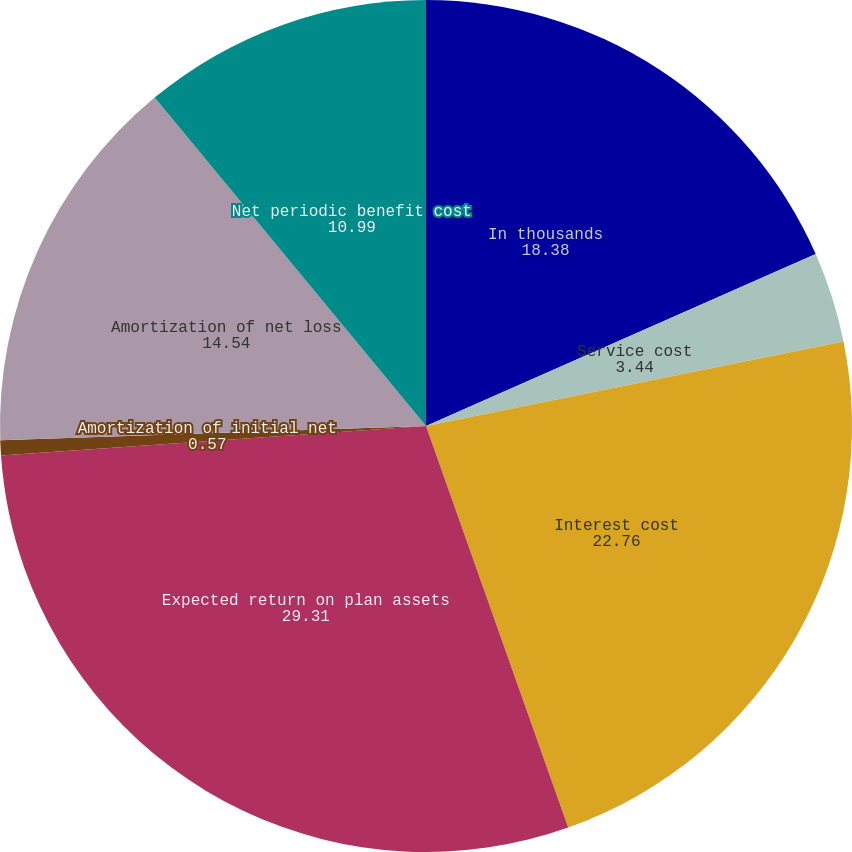<chart> <loc_0><loc_0><loc_500><loc_500><pie_chart><fcel>In thousands<fcel>Service cost<fcel>Interest cost<fcel>Expected return on plan assets<fcel>Amortization of initial net<fcel>Amortization of net loss<fcel>Net periodic benefit cost<nl><fcel>18.38%<fcel>3.44%<fcel>22.76%<fcel>29.31%<fcel>0.57%<fcel>14.54%<fcel>10.99%<nl></chart> 